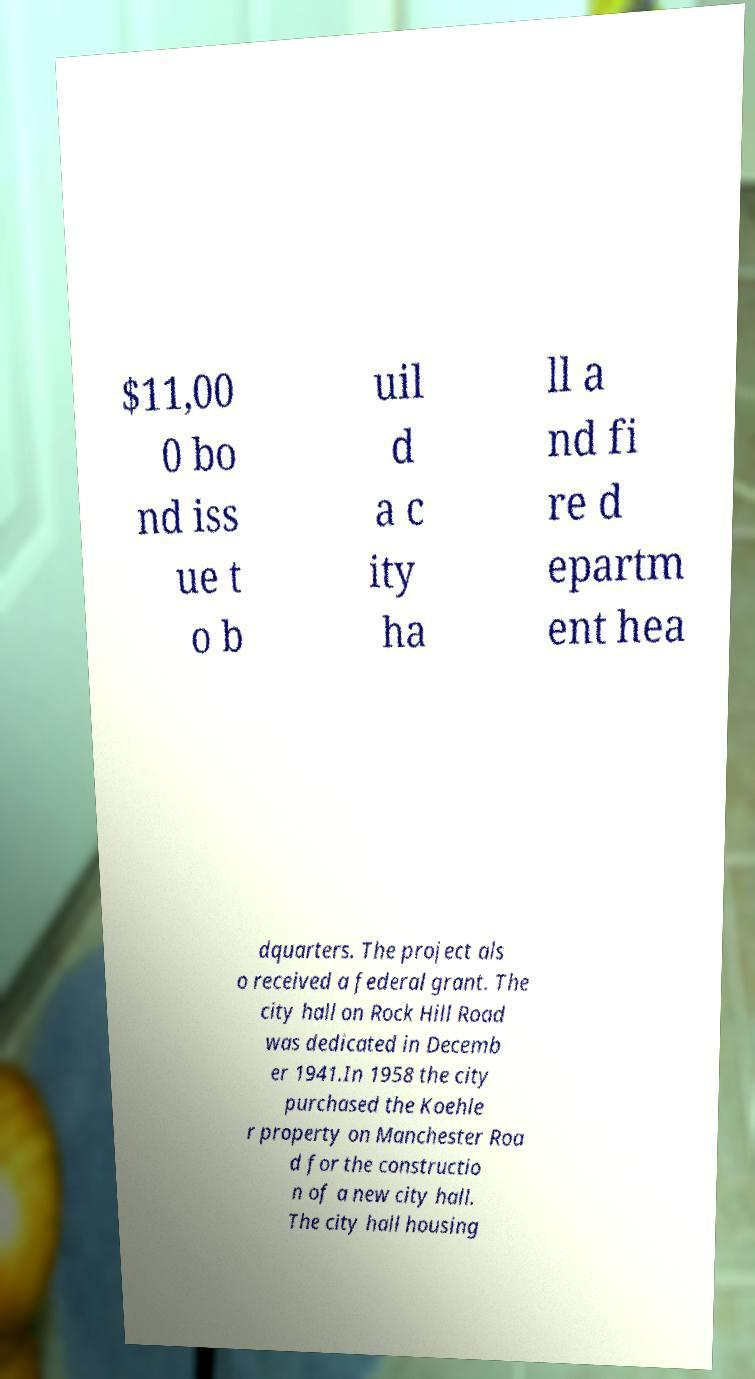I need the written content from this picture converted into text. Can you do that? $11,00 0 bo nd iss ue t o b uil d a c ity ha ll a nd fi re d epartm ent hea dquarters. The project als o received a federal grant. The city hall on Rock Hill Road was dedicated in Decemb er 1941.In 1958 the city purchased the Koehle r property on Manchester Roa d for the constructio n of a new city hall. The city hall housing 